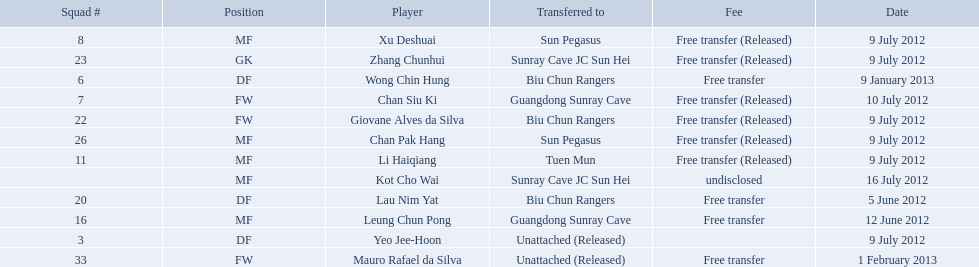Which players are listed? Lau Nim Yat, Leung Chun Pong, Yeo Jee-Hoon, Xu Deshuai, Li Haiqiang, Giovane Alves da Silva, Zhang Chunhui, Chan Pak Hang, Chan Siu Ki, Kot Cho Wai, Wong Chin Hung, Mauro Rafael da Silva. Which dates were players transferred to the biu chun rangers? 5 June 2012, 9 July 2012, 9 January 2013. Of those which is the date for wong chin hung? 9 January 2013. 